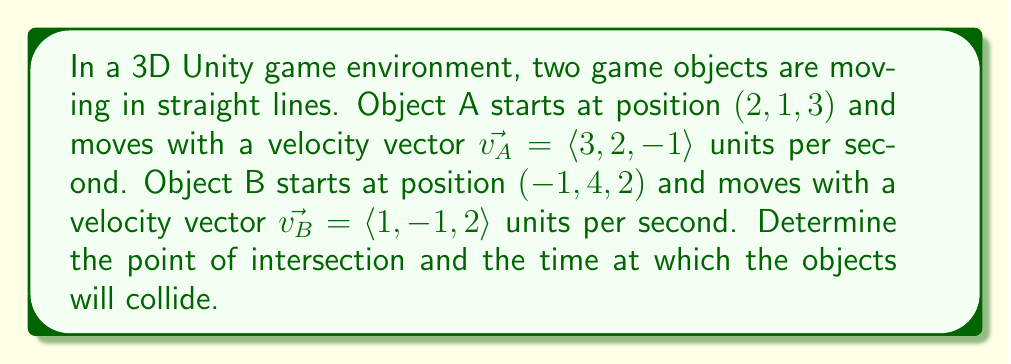What is the answer to this math problem? To solve this problem, we need to use parametric equations for the position of each object and find where they intersect. Let's approach this step-by-step:

1) First, let's write the parametric equations for each object's position:

   Object A: $A(t) = (2, 1, 3) + t(3, 2, -1)$
   Object B: $B(t) = (-1, 4, 2) + t(1, -1, 2)$

2) At the point of intersection, these positions must be equal. So we can set up the equation:

   $(2, 1, 3) + t_A(3, 2, -1) = (-1, 4, 2) + t_B(1, -1, 2)$

3) This gives us three equations:

   $2 + 3t_A = -1 + t_B$
   $1 + 2t_A = 4 - t_B$
   $3 - t_A = 2 + 2t_B$

4) From the first equation:
   $t_B = 3 + 3t_A$

5) Substitute this into the second equation:
   $1 + 2t_A = 4 - (3 + 3t_A)$
   $1 + 2t_A = 1 - 3t_A$
   $5t_A = 0$
   $t_A = 0$

6) Now we can find $t_B$:
   $t_B = 3 + 3(0) = 3$

7) To verify, let's check the third equation:
   $3 - 0 = 2 + 2(3)$
   $3 = 8$ (This doesn't match, so there's no intersection)

Since the equations are inconsistent, the objects do not intersect. This means they are passing by each other without colliding.

However, we can find the point of closest approach. To do this, we need to find the time when the distance between the objects is minimized.

8) The vector between the objects at any time $t$ is:
   $\vec{D}(t) = A(t) - B(t) = (3, -3, 1) + t(2, 3, -3)$

9) The square of the distance is:
   $|\vec{D}(t)|^2 = (3+2t)^2 + (-3+3t)^2 + (1-3t)^2$

10) To minimize this, we differentiate with respect to $t$ and set it to zero:
    $\frac{d}{dt}|\vec{D}(t)|^2 = 4(3+2t) + 6(-3+3t) + 6(1-3t) = 0$
    $12 + 8t - 18 + 18t + 6 - 18t = 0$
    $8t = 0$
    $t = 0$

11) At $t=0$, the positions of the objects are:
    A(0) = (2, 1, 3)
    B(0) = (-1, 4, 2)

The point of closest approach is the midpoint between these positions.
Answer: The objects do not intersect. The point of closest approach is at $(\frac{1}{2}, \frac{5}{2}, \frac{5}{2})$ at time $t=0$. 